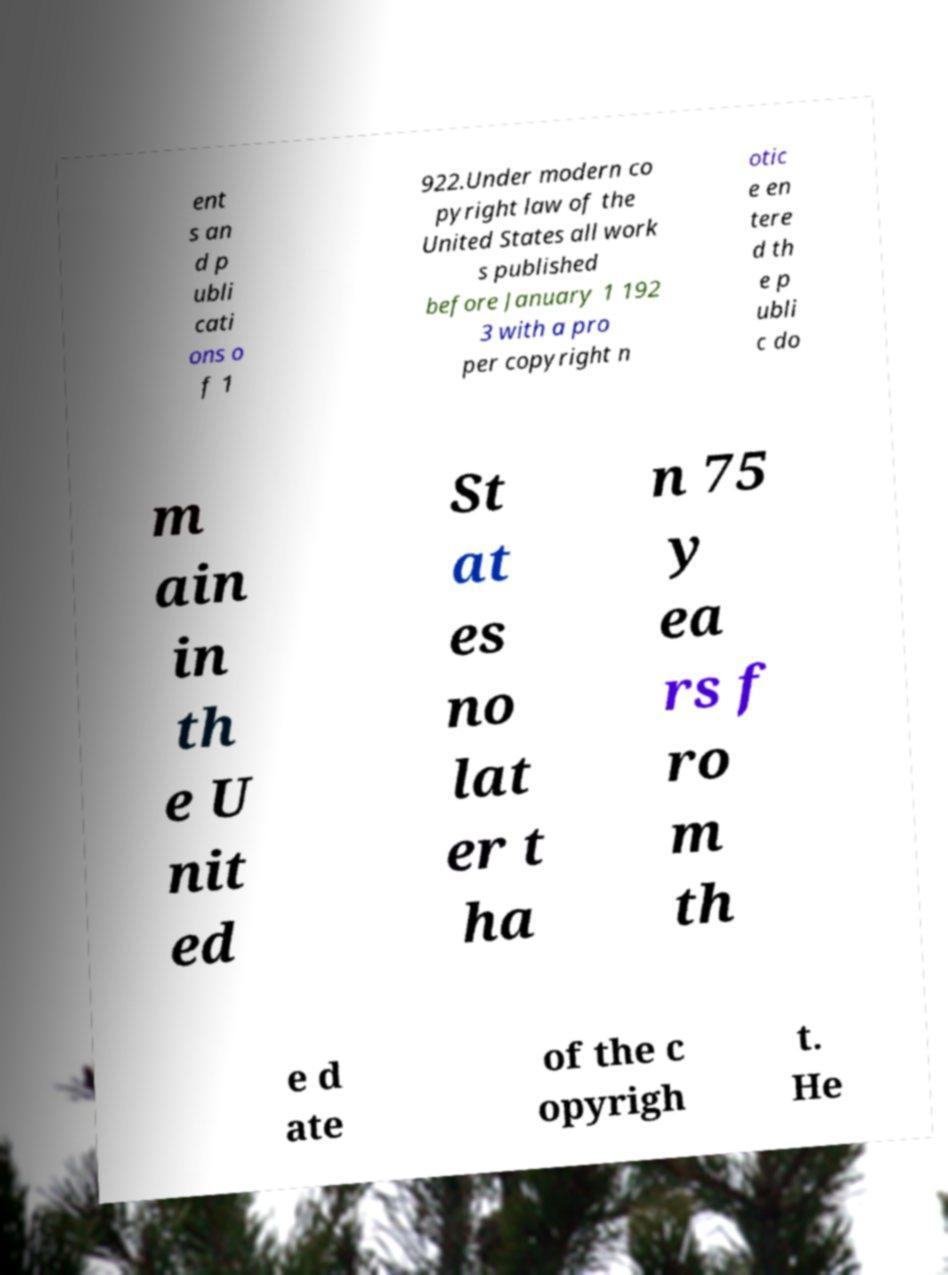For documentation purposes, I need the text within this image transcribed. Could you provide that? ent s an d p ubli cati ons o f 1 922.Under modern co pyright law of the United States all work s published before January 1 192 3 with a pro per copyright n otic e en tere d th e p ubli c do m ain in th e U nit ed St at es no lat er t ha n 75 y ea rs f ro m th e d ate of the c opyrigh t. He 